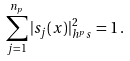<formula> <loc_0><loc_0><loc_500><loc_500>\sum _ { j = 1 } ^ { n _ { p } } | s _ { j } ( x ) | ^ { 2 } _ { h ^ { p } _ { \ } s } = 1 \, .</formula> 